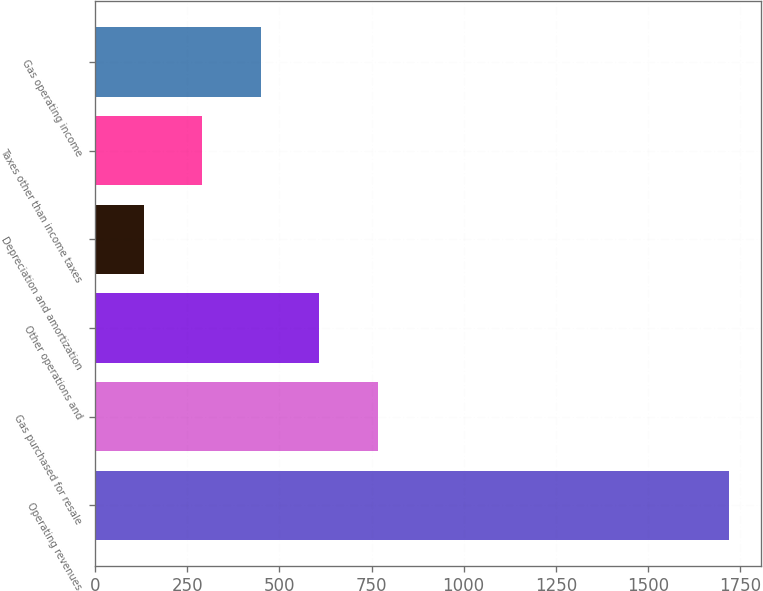<chart> <loc_0><loc_0><loc_500><loc_500><bar_chart><fcel>Operating revenues<fcel>Gas purchased for resale<fcel>Other operations and<fcel>Depreciation and amortization<fcel>Taxes other than income taxes<fcel>Gas operating income<nl><fcel>1721<fcel>767.6<fcel>608.7<fcel>132<fcel>290.9<fcel>449.8<nl></chart> 